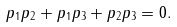Convert formula to latex. <formula><loc_0><loc_0><loc_500><loc_500>p _ { 1 } p _ { 2 } + p _ { 1 } p _ { 3 } + p _ { 2 } p _ { 3 } = 0 .</formula> 